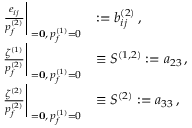<formula> <loc_0><loc_0><loc_500><loc_500>\begin{array} { r l } { \frac { e _ { i j } } { p _ { f } ^ { ( 2 ) } } \right | _ { { \sigma = 0 } , \, p _ { f } ^ { ( 1 ) } = 0 } } & { \colon = b _ { i j } ^ { ( 2 ) } \, , } \\ { \frac { \zeta ^ { ( 1 ) } } { p _ { f } ^ { ( 2 ) } } \right | _ { { \sigma = 0 } , \, p _ { f } ^ { ( 1 ) } = 0 } } & { \equiv S ^ { ( 1 , 2 ) } \colon = a _ { 2 3 } \, , } \\ { \frac { \zeta ^ { ( 2 ) } } { p _ { f } ^ { ( 2 ) } } \right | _ { { \sigma = 0 } , \, p _ { f } ^ { ( 1 ) } = 0 } } & { \equiv S ^ { ( 2 ) } \colon = a _ { 3 3 } \, , } \end{array}</formula> 